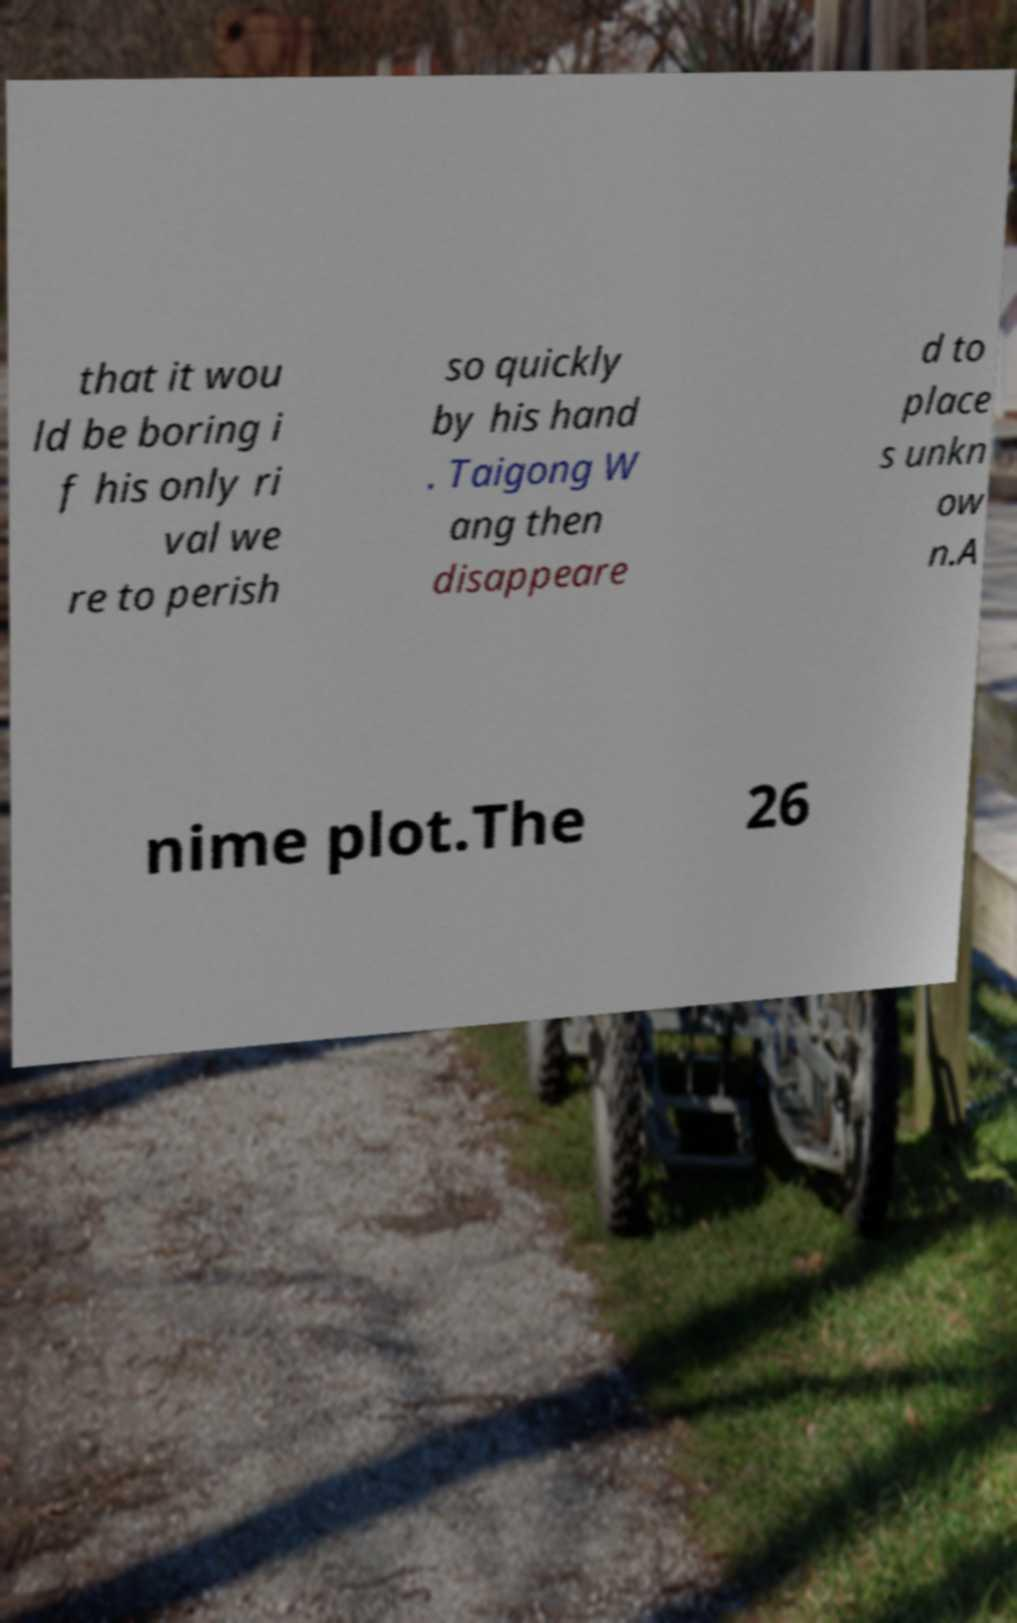Please identify and transcribe the text found in this image. that it wou ld be boring i f his only ri val we re to perish so quickly by his hand . Taigong W ang then disappeare d to place s unkn ow n.A nime plot.The 26 